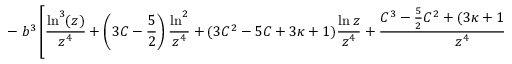Convert formula to latex. <formula><loc_0><loc_0><loc_500><loc_500>- b ^ { 3 } \left [ \frac { \ln ^ { 3 } ( z ) } { z ^ { 4 } } + \left ( 3 C - \frac { 5 } { 2 } \right ) \frac { \ln ^ { 2 } } { z ^ { 4 } } + ( 3 C ^ { 2 } - 5 C + 3 \kappa + 1 ) \frac { \ln z } { z ^ { 4 } } + \frac { C ^ { 3 } - \frac { 5 } { 2 } C ^ { 2 } + ( 3 \kappa + 1 ) C + \bar { \kappa } } { z ^ { 4 } } \right ] \right \} .</formula> 